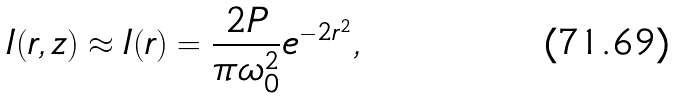<formula> <loc_0><loc_0><loc_500><loc_500>I ( r , z ) \approx I ( r ) = \frac { 2 P } { \pi \omega _ { 0 } ^ { 2 } } e ^ { - 2 r ^ { 2 } } ,</formula> 